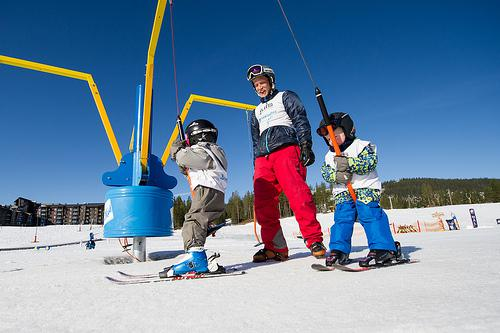Question: what activity is depicted here?
Choices:
A. Skiing.
B. Celebration.
C. Skateboarding.
D. Surfing.
Answer with the letter. Answer: A Question: how many children are there?
Choices:
A. Two.
B. Three.
C. Four.
D. Five.
Answer with the letter. Answer: A Question: who is wearing the red ski pants?
Choices:
A. A girl.
B. The adult.
C. A boy.
D. A skier.
Answer with the letter. Answer: B Question: how would the weather be described?
Choices:
A. Cloudy.
B. Sunny with clear skies.
C. Overcast.
D. Rainy.
Answer with the letter. Answer: B Question: what is in the background on the left?
Choices:
A. Traffic lights.
B. Trees.
C. Houses.
D. A building.
Answer with the letter. Answer: D 